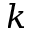<formula> <loc_0><loc_0><loc_500><loc_500>k</formula> 